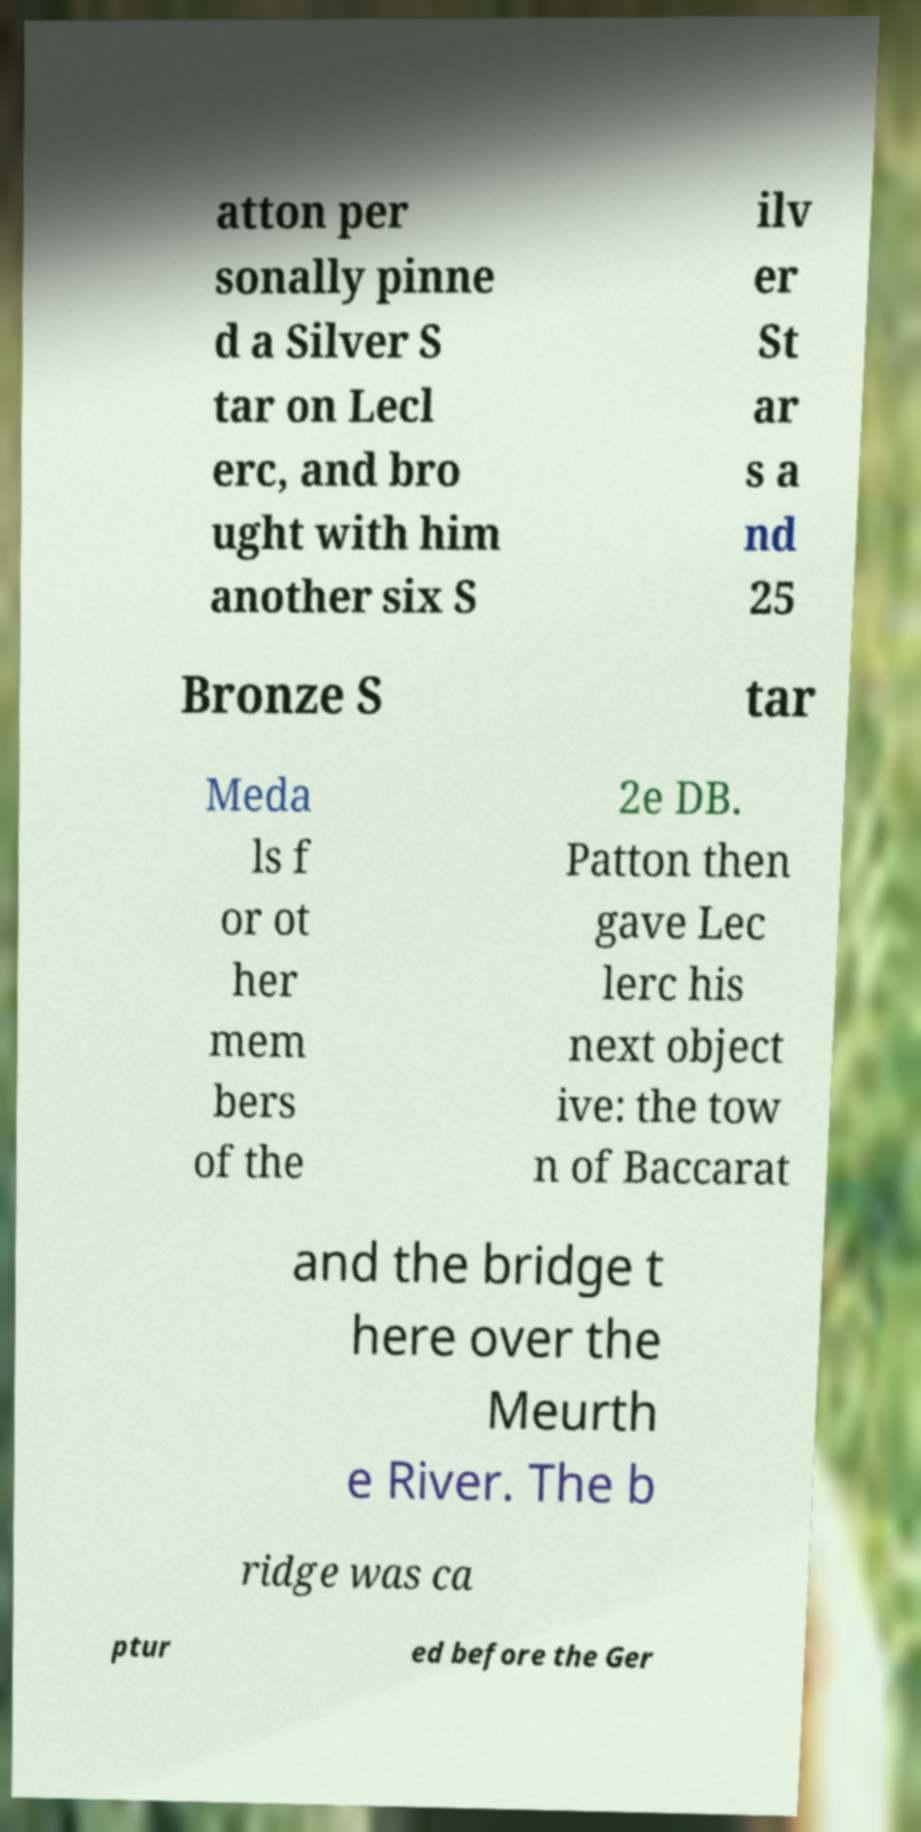Can you accurately transcribe the text from the provided image for me? atton per sonally pinne d a Silver S tar on Lecl erc, and bro ught with him another six S ilv er St ar s a nd 25 Bronze S tar Meda ls f or ot her mem bers of the 2e DB. Patton then gave Lec lerc his next object ive: the tow n of Baccarat and the bridge t here over the Meurth e River. The b ridge was ca ptur ed before the Ger 